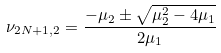Convert formula to latex. <formula><loc_0><loc_0><loc_500><loc_500>\nu _ { 2 N + 1 , 2 } = \frac { - \mu _ { 2 } \pm \sqrt { \mu _ { 2 } ^ { 2 } - 4 \mu _ { 1 } } } { 2 \mu _ { 1 } }</formula> 